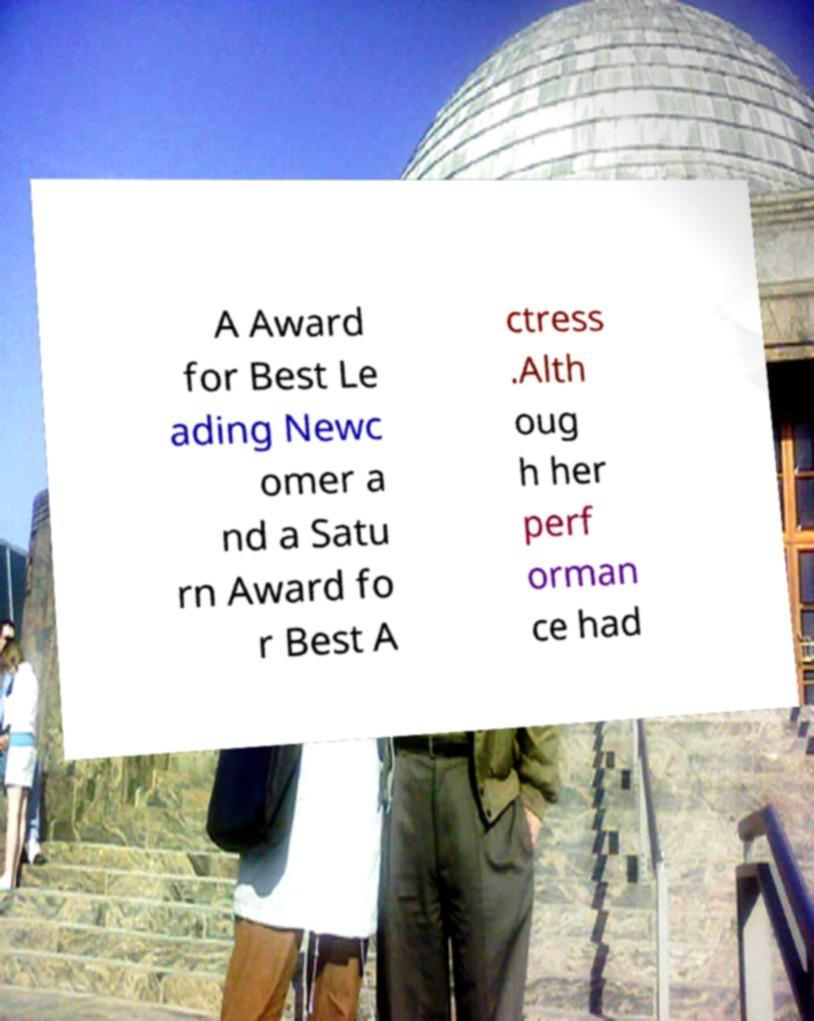What messages or text are displayed in this image? I need them in a readable, typed format. A Award for Best Le ading Newc omer a nd a Satu rn Award fo r Best A ctress .Alth oug h her perf orman ce had 